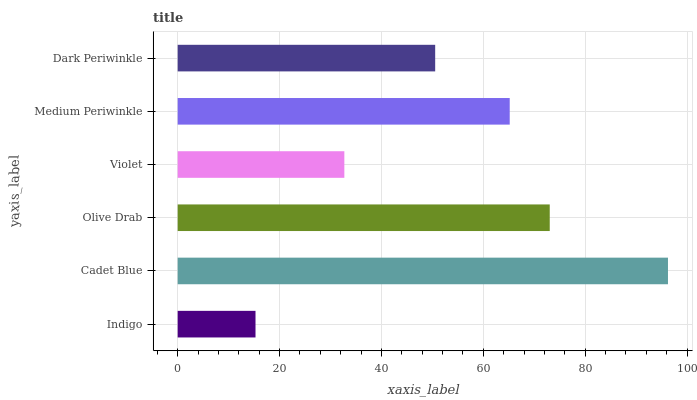Is Indigo the minimum?
Answer yes or no. Yes. Is Cadet Blue the maximum?
Answer yes or no. Yes. Is Olive Drab the minimum?
Answer yes or no. No. Is Olive Drab the maximum?
Answer yes or no. No. Is Cadet Blue greater than Olive Drab?
Answer yes or no. Yes. Is Olive Drab less than Cadet Blue?
Answer yes or no. Yes. Is Olive Drab greater than Cadet Blue?
Answer yes or no. No. Is Cadet Blue less than Olive Drab?
Answer yes or no. No. Is Medium Periwinkle the high median?
Answer yes or no. Yes. Is Dark Periwinkle the low median?
Answer yes or no. Yes. Is Dark Periwinkle the high median?
Answer yes or no. No. Is Olive Drab the low median?
Answer yes or no. No. 